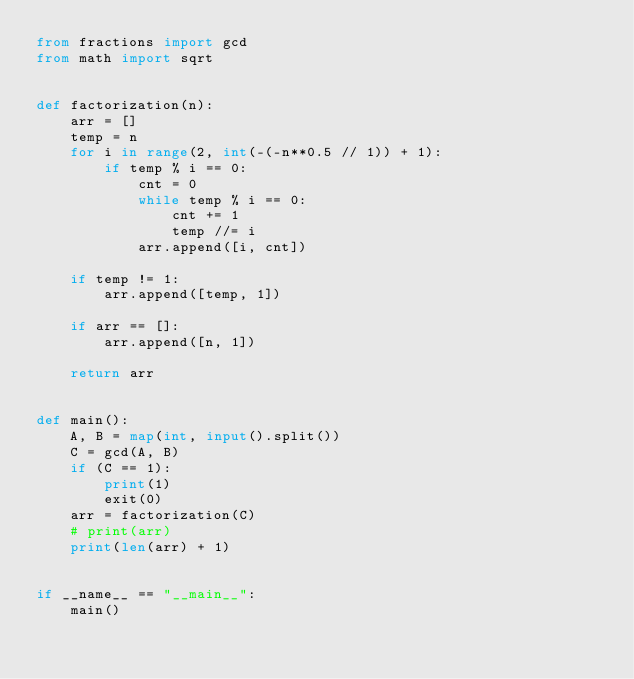Convert code to text. <code><loc_0><loc_0><loc_500><loc_500><_Python_>from fractions import gcd
from math import sqrt


def factorization(n):
    arr = []
    temp = n
    for i in range(2, int(-(-n**0.5 // 1)) + 1):
        if temp % i == 0:
            cnt = 0
            while temp % i == 0:
                cnt += 1
                temp //= i
            arr.append([i, cnt])

    if temp != 1:
        arr.append([temp, 1])

    if arr == []:
        arr.append([n, 1])

    return arr


def main():
    A, B = map(int, input().split())
    C = gcd(A, B)
    if (C == 1):
        print(1)
        exit(0)
    arr = factorization(C)
    # print(arr)
    print(len(arr) + 1)


if __name__ == "__main__":
    main()
</code> 